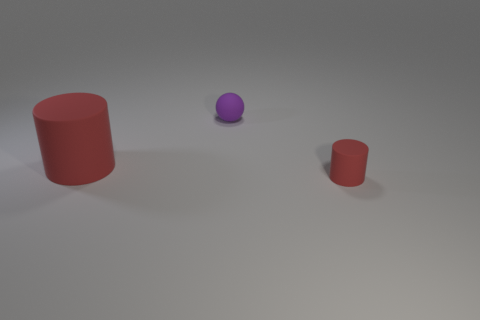Add 1 tiny red objects. How many objects exist? 4 Subtract all cylinders. How many objects are left? 1 Add 2 large yellow balls. How many large yellow balls exist? 2 Subtract 0 cyan blocks. How many objects are left? 3 Subtract all small matte spheres. Subtract all large things. How many objects are left? 1 Add 1 large cylinders. How many large cylinders are left? 2 